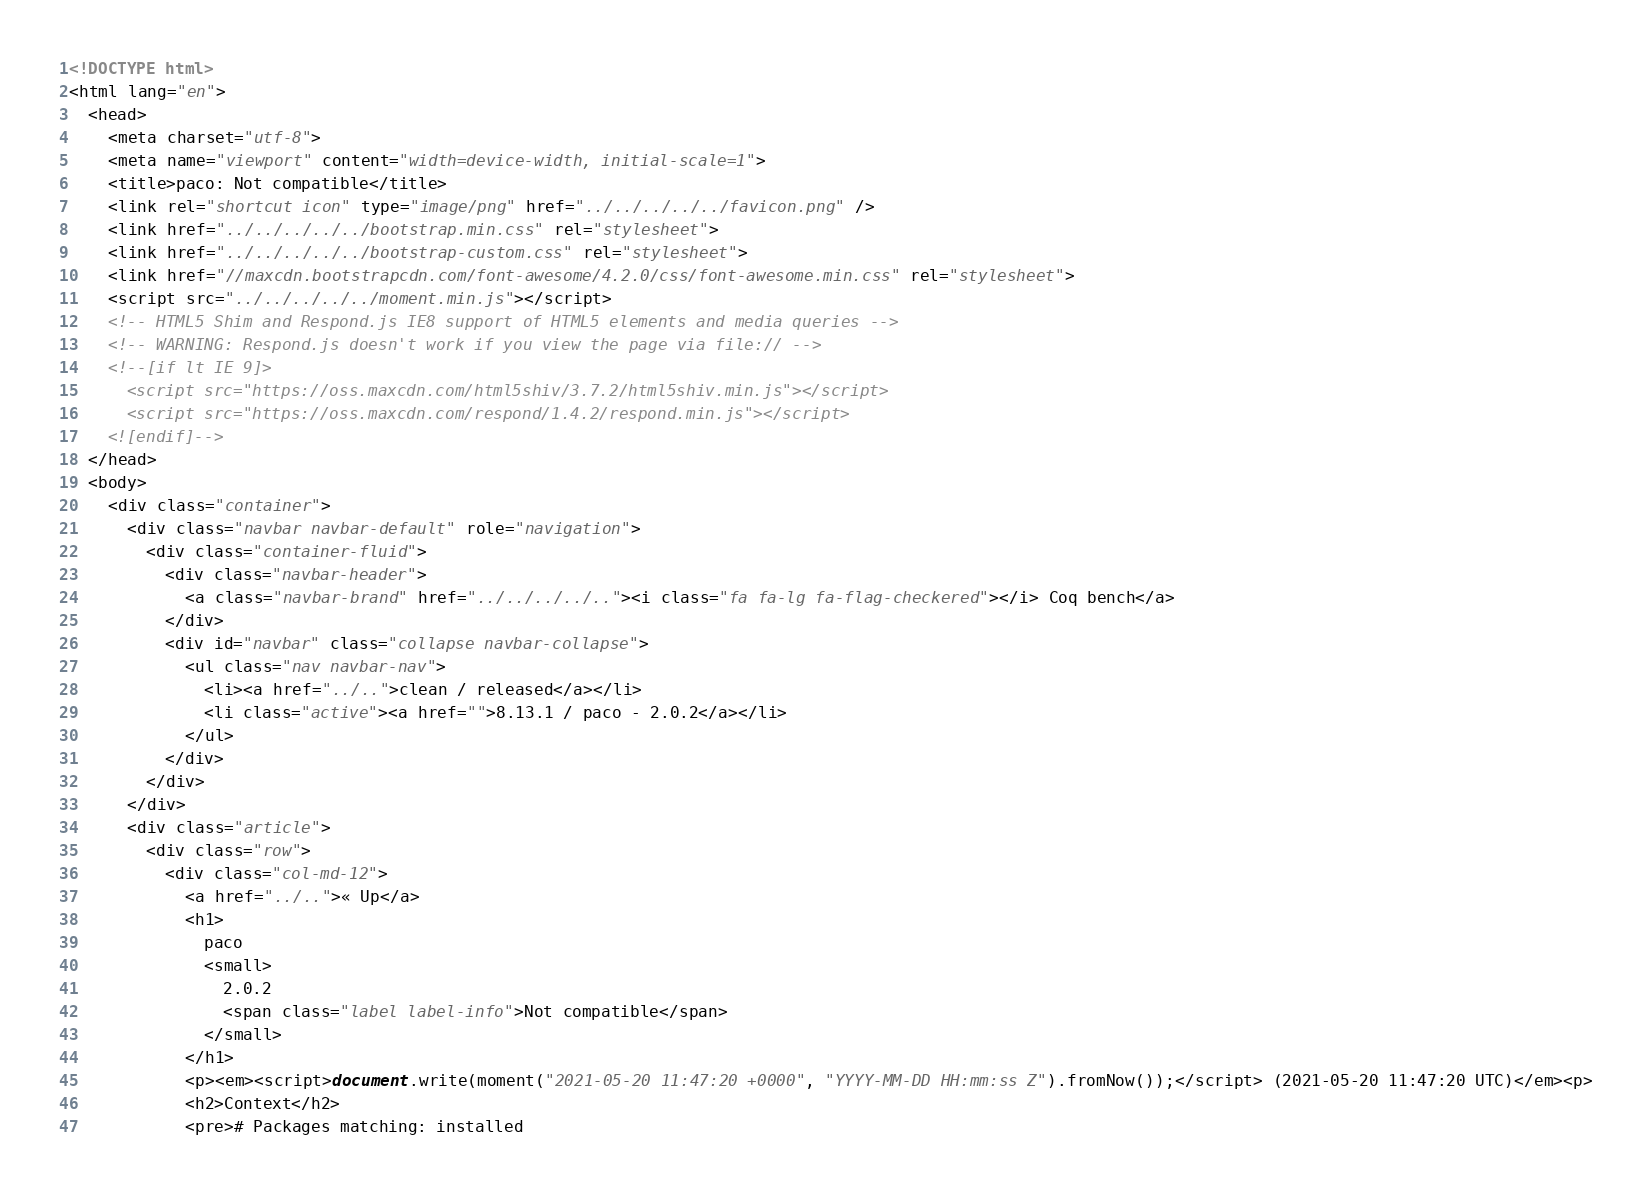Convert code to text. <code><loc_0><loc_0><loc_500><loc_500><_HTML_><!DOCTYPE html>
<html lang="en">
  <head>
    <meta charset="utf-8">
    <meta name="viewport" content="width=device-width, initial-scale=1">
    <title>paco: Not compatible</title>
    <link rel="shortcut icon" type="image/png" href="../../../../../favicon.png" />
    <link href="../../../../../bootstrap.min.css" rel="stylesheet">
    <link href="../../../../../bootstrap-custom.css" rel="stylesheet">
    <link href="//maxcdn.bootstrapcdn.com/font-awesome/4.2.0/css/font-awesome.min.css" rel="stylesheet">
    <script src="../../../../../moment.min.js"></script>
    <!-- HTML5 Shim and Respond.js IE8 support of HTML5 elements and media queries -->
    <!-- WARNING: Respond.js doesn't work if you view the page via file:// -->
    <!--[if lt IE 9]>
      <script src="https://oss.maxcdn.com/html5shiv/3.7.2/html5shiv.min.js"></script>
      <script src="https://oss.maxcdn.com/respond/1.4.2/respond.min.js"></script>
    <![endif]-->
  </head>
  <body>
    <div class="container">
      <div class="navbar navbar-default" role="navigation">
        <div class="container-fluid">
          <div class="navbar-header">
            <a class="navbar-brand" href="../../../../.."><i class="fa fa-lg fa-flag-checkered"></i> Coq bench</a>
          </div>
          <div id="navbar" class="collapse navbar-collapse">
            <ul class="nav navbar-nav">
              <li><a href="../..">clean / released</a></li>
              <li class="active"><a href="">8.13.1 / paco - 2.0.2</a></li>
            </ul>
          </div>
        </div>
      </div>
      <div class="article">
        <div class="row">
          <div class="col-md-12">
            <a href="../..">« Up</a>
            <h1>
              paco
              <small>
                2.0.2
                <span class="label label-info">Not compatible</span>
              </small>
            </h1>
            <p><em><script>document.write(moment("2021-05-20 11:47:20 +0000", "YYYY-MM-DD HH:mm:ss Z").fromNow());</script> (2021-05-20 11:47:20 UTC)</em><p>
            <h2>Context</h2>
            <pre># Packages matching: installed</code> 